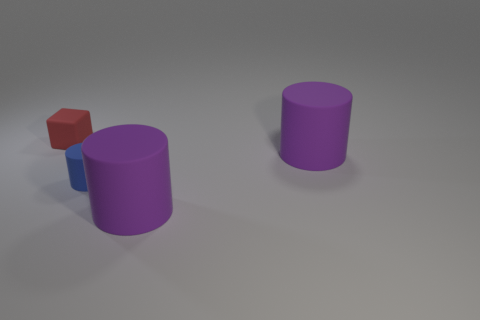What number of things are either small objects that are in front of the block or big yellow shiny balls?
Provide a short and direct response. 1. There is a thing on the left side of the blue thing; what is its size?
Offer a terse response. Small. What number of other things are the same material as the red cube?
Make the answer very short. 3. Is the number of large red matte objects greater than the number of tiny red things?
Offer a very short reply. No. What is the color of the small cylinder?
Offer a terse response. Blue. There is a small rubber thing that is in front of the small red matte cube; is there a big purple thing in front of it?
Ensure brevity in your answer.  Yes. What is the shape of the red thing that is behind the big thing in front of the blue cylinder?
Provide a short and direct response. Cube. Is the number of green blocks less than the number of small things?
Ensure brevity in your answer.  Yes. Is the material of the small blue cylinder the same as the tiny block?
Give a very brief answer. Yes. What color is the rubber object that is behind the blue thing and in front of the red rubber cube?
Provide a succinct answer. Purple. 